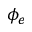<formula> <loc_0><loc_0><loc_500><loc_500>\phi _ { e }</formula> 